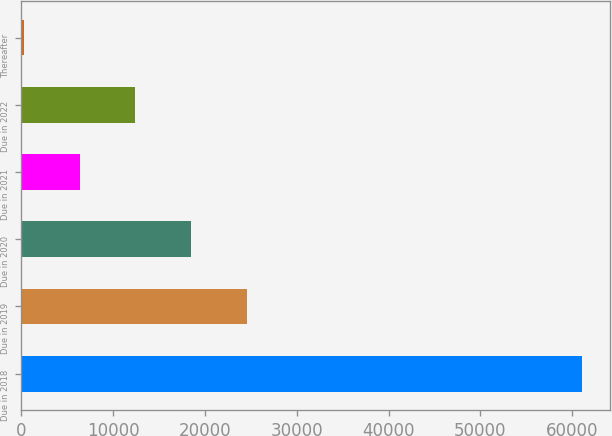Convert chart. <chart><loc_0><loc_0><loc_500><loc_500><bar_chart><fcel>Due in 2018<fcel>Due in 2019<fcel>Due in 2020<fcel>Due in 2021<fcel>Due in 2022<fcel>Thereafter<nl><fcel>61038<fcel>24579<fcel>18502.5<fcel>6349.5<fcel>12426<fcel>273<nl></chart> 